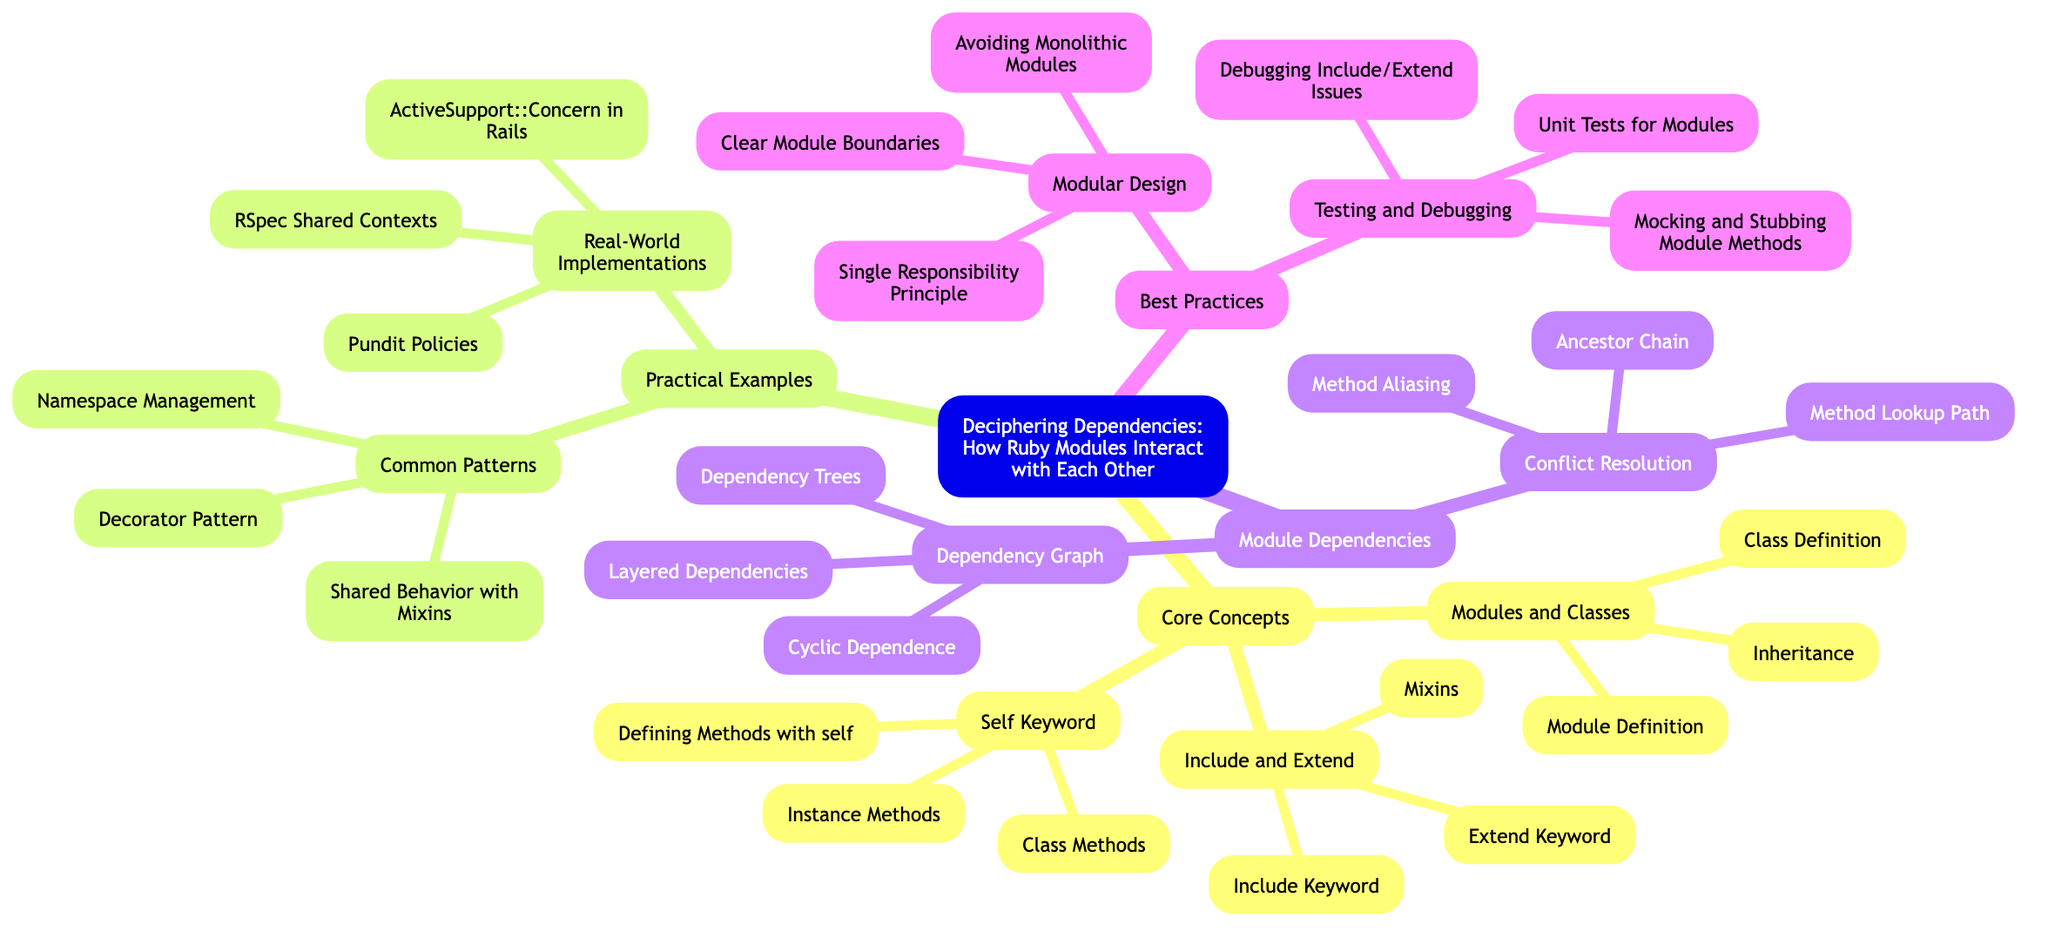What is the first main category under the root? The root node is "Deciphering Dependencies: How Ruby Modules Interact with Each Other." The first main category listed directly beneath it is "Core Concepts."
Answer: Core Concepts How many items are listed under "Include and Extend"? Under the category "Include and Extend," there are three specific items: "Include Keyword," "Extend Keyword," and "Mixins." Thus, the total number of items listed is three.
Answer: 3 Which section includes "ActiveSupport::Concern in Rails"? The item "ActiveSupport::Concern in Rails" is found in the "Real-World Implementations" category, which is a subcategory of "Practical Examples."
Answer: Real-World Implementations What are the two subcategories under "Module Dependencies"? The "Module Dependencies" category has two subcategories named "Dependency Graph" and "Conflict Resolution."
Answer: Dependency Graph, Conflict Resolution How does "Single Responsibility Principle" relate to "Best Practices"? The "Single Responsibility Principle" is one item under the "Modular Design" subcategory, which is itself part of the main category "Best Practices." Therefore, it fits into the hierarchy as a specific guideline for module design within the broader best practices framework.
Answer: Modular Design What is the method of conflict resolution listed first? The first item listed under "Conflict Resolution" is "Method Lookup Path," which addresses how Ruby determines which method to execute when there are conflicts.
Answer: Method Lookup Path How many main categories are present in this mind map? The mind map contains four main categories, which are "Core Concepts," "Practical Examples," "Module Dependencies," and "Best Practices." Thus, the total main categories add up to four.
Answer: 4 Which item emphasizes testing and debugging? The item that emphasizes testing and debugging is "Testing and Debugging," which has its own subcategory under "Best Practices." This indicates the importance of ensuring module integrity through testing.
Answer: Testing and Debugging What relationship does "Mixins" have with "Include and Extend"? "Mixins" is listed as one of the items under the "Include and Extend" category, indicating it is a concept related to how modules can be included in classes or extended in functionality within Ruby.
Answer: Include and Extend 